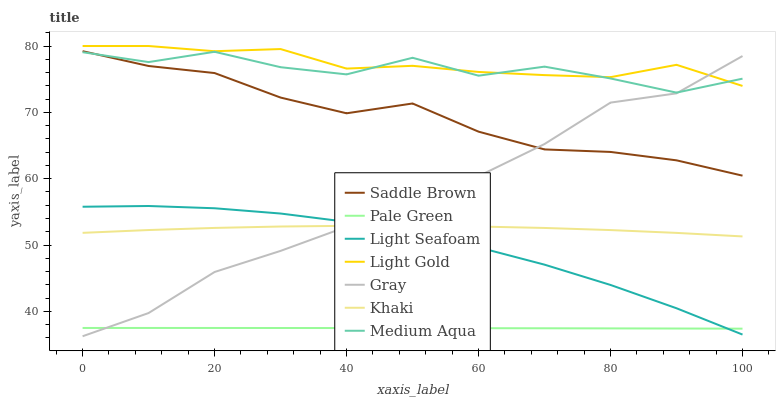Does Pale Green have the minimum area under the curve?
Answer yes or no. Yes. Does Light Gold have the maximum area under the curve?
Answer yes or no. Yes. Does Khaki have the minimum area under the curve?
Answer yes or no. No. Does Khaki have the maximum area under the curve?
Answer yes or no. No. Is Pale Green the smoothest?
Answer yes or no. Yes. Is Medium Aqua the roughest?
Answer yes or no. Yes. Is Khaki the smoothest?
Answer yes or no. No. Is Khaki the roughest?
Answer yes or no. No. Does Khaki have the lowest value?
Answer yes or no. No. Does Khaki have the highest value?
Answer yes or no. No. Is Pale Green less than Saddle Brown?
Answer yes or no. Yes. Is Khaki greater than Pale Green?
Answer yes or no. Yes. Does Pale Green intersect Saddle Brown?
Answer yes or no. No. 